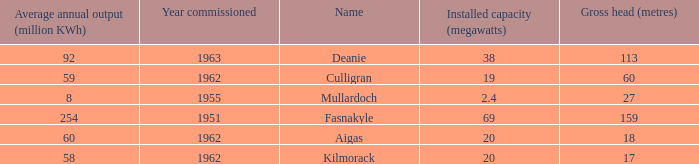What is the earliest Year commissioned wiht an Average annual output greater than 58 and Installed capacity of 20? 1962.0. 